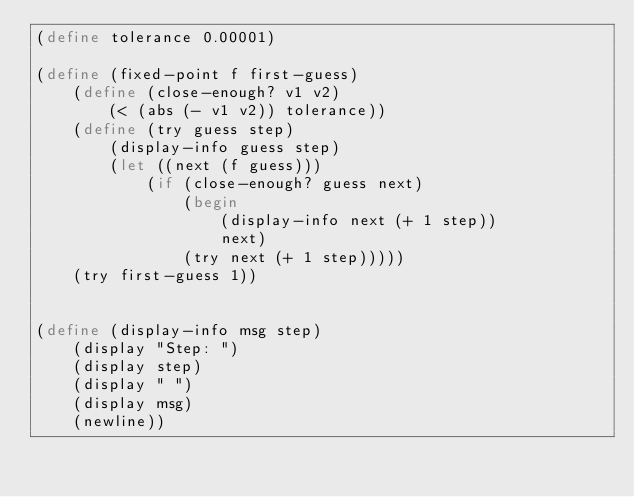Convert code to text. <code><loc_0><loc_0><loc_500><loc_500><_Scheme_>(define tolerance 0.00001)

(define (fixed-point f first-guess)
	(define (close-enough? v1 v2)
		(< (abs (- v1 v2)) tolerance))
	(define (try guess step)
		(display-info guess step)
		(let ((next (f guess)))
			(if (close-enough? guess next)
				(begin 
					(display-info next (+ 1 step))
					next)
				(try next (+ 1 step)))))
	(try first-guess 1))


(define (display-info msg step)
	(display "Step: ")
	(display step)
	(display " ")
	(display msg)
	(newline))
</code> 